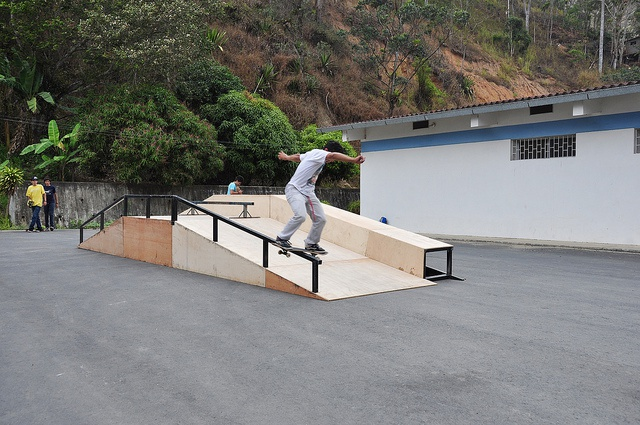Describe the objects in this image and their specific colors. I can see people in black, darkgray, lavender, and gray tones, people in black, khaki, and navy tones, people in black, gray, and navy tones, skateboard in black, gray, lightgray, and darkgray tones, and people in black, lightblue, brown, and gray tones in this image. 